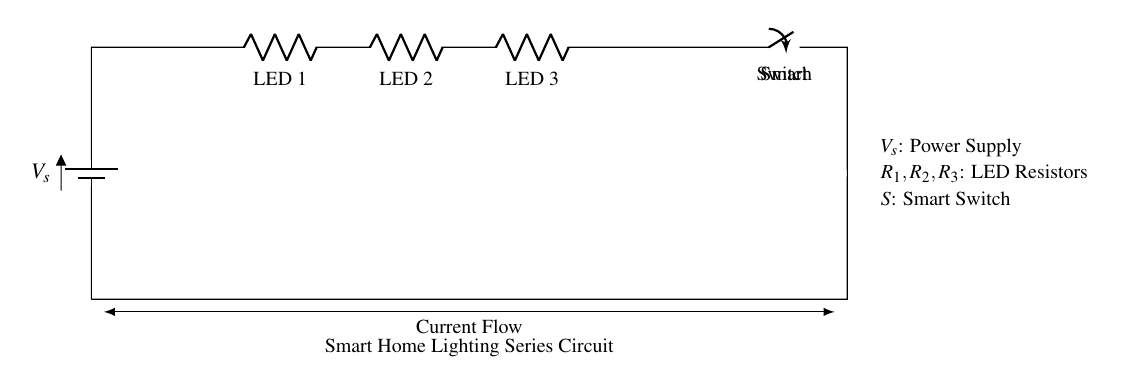What type of circuit is shown? The circuit is a series circuit, indicated by the connection of all components in a single loop with no branching.
Answer: series circuit How many resistive loads are present? There are three resistors present in the circuit, represented by LED 1, LED 2, and LED 3, each acting as a load.
Answer: three What is the role of the smart switch? The smart switch is used to control the flow of current in the circuit, allowing the user to turn the lighting on or off as required.
Answer: control current What happens to the brightness of the LEDs if one LED fails? If one LED fails, the entire circuit will become open, resulting in all LEDs turning off due to the characteristics of a series circuit.
Answer: all off What does the symbol next to "Smart Switch" indicate? The symbol indicates that it is a manually controlled switch which can be toggled to change the state of the circuit.
Answer: toggle switch Is the current flowing through all the components equal? Yes, in a series circuit, the same current flows through all components, which maintains a consistent flow throughout the circuit.
Answer: yes What is the voltage source in this circuit? The voltage source is represented by V_s, typically indicating the power supply connected to the circuit.
Answer: V_s 